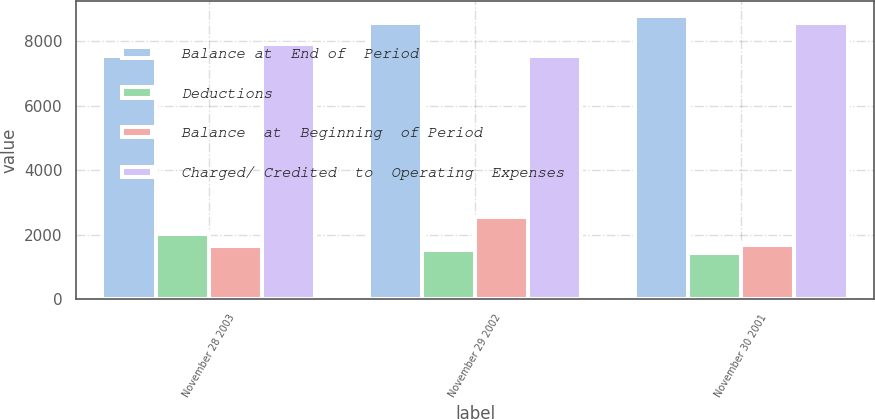<chart> <loc_0><loc_0><loc_500><loc_500><stacked_bar_chart><ecel><fcel>November 28 2003<fcel>November 29 2002<fcel>November 30 2001<nl><fcel>Balance at  End of  Period<fcel>7531<fcel>8549<fcel>8788<nl><fcel>Deductions<fcel>2038<fcel>1527<fcel>1435<nl><fcel>Balance  at  Beginning  of Period<fcel>1666<fcel>2545<fcel>1674<nl><fcel>Charged/ Credited  to  Operating  Expenses<fcel>7903<fcel>7531<fcel>8549<nl></chart> 